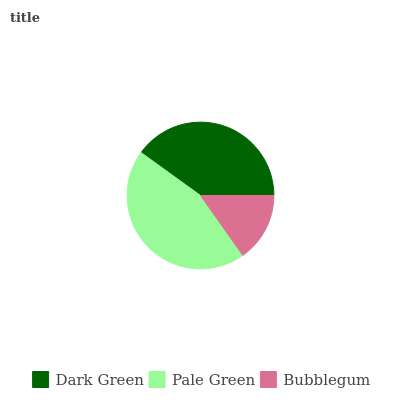Is Bubblegum the minimum?
Answer yes or no. Yes. Is Pale Green the maximum?
Answer yes or no. Yes. Is Pale Green the minimum?
Answer yes or no. No. Is Bubblegum the maximum?
Answer yes or no. No. Is Pale Green greater than Bubblegum?
Answer yes or no. Yes. Is Bubblegum less than Pale Green?
Answer yes or no. Yes. Is Bubblegum greater than Pale Green?
Answer yes or no. No. Is Pale Green less than Bubblegum?
Answer yes or no. No. Is Dark Green the high median?
Answer yes or no. Yes. Is Dark Green the low median?
Answer yes or no. Yes. Is Bubblegum the high median?
Answer yes or no. No. Is Bubblegum the low median?
Answer yes or no. No. 